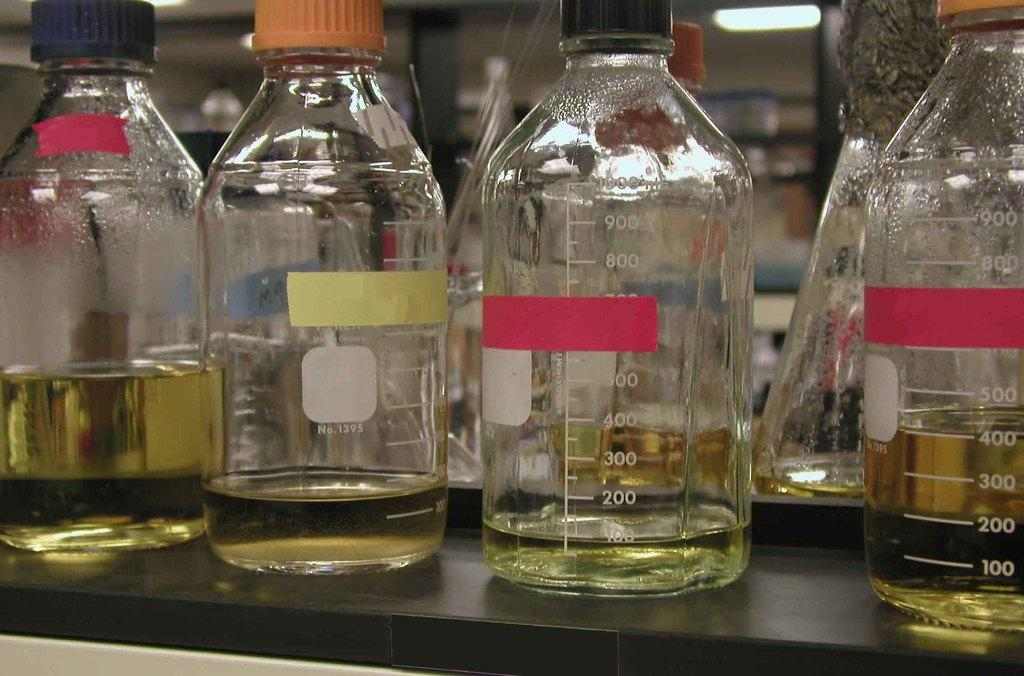<image>
Write a terse but informative summary of the picture. Jars with a yellowish liquid in them with the most filled done having 400 ml in it. 